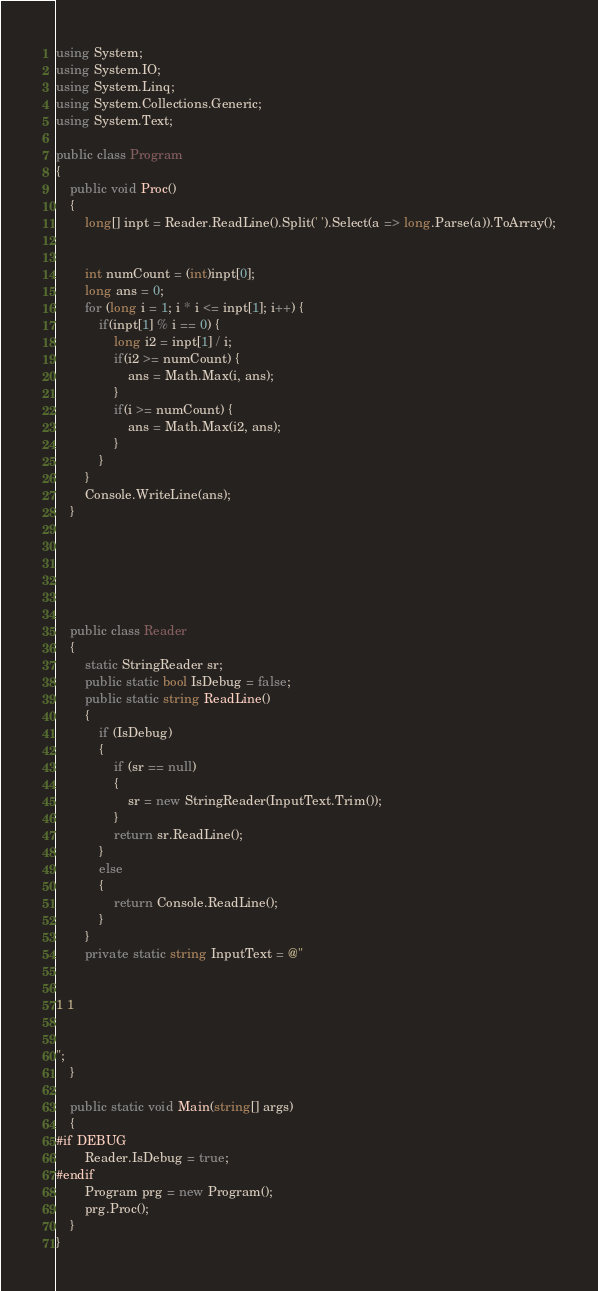Convert code to text. <code><loc_0><loc_0><loc_500><loc_500><_C#_>using System;
using System.IO;
using System.Linq;
using System.Collections.Generic;
using System.Text;

public class Program
{
    public void Proc()
    {
        long[] inpt = Reader.ReadLine().Split(' ').Select(a => long.Parse(a)).ToArray();


        int numCount = (int)inpt[0];
        long ans = 0;
        for (long i = 1; i * i <= inpt[1]; i++) {
            if(inpt[1] % i == 0) {
                long i2 = inpt[1] / i;
                if(i2 >= numCount) {
                    ans = Math.Max(i, ans);
                }
                if(i >= numCount) {
                    ans = Math.Max(i2, ans);
                }
            }
        }
        Console.WriteLine(ans);
    }






    public class Reader
    {
        static StringReader sr;
        public static bool IsDebug = false;
        public static string ReadLine()
        {
            if (IsDebug)
            {
                if (sr == null)
                {
                    sr = new StringReader(InputText.Trim());
                }
                return sr.ReadLine();
            }
            else
            {
                return Console.ReadLine();
            }
        }
        private static string InputText = @"


1 1


";
    }

    public static void Main(string[] args)
    {
#if DEBUG
        Reader.IsDebug = true;
#endif
        Program prg = new Program();
        prg.Proc();
    }
}
</code> 